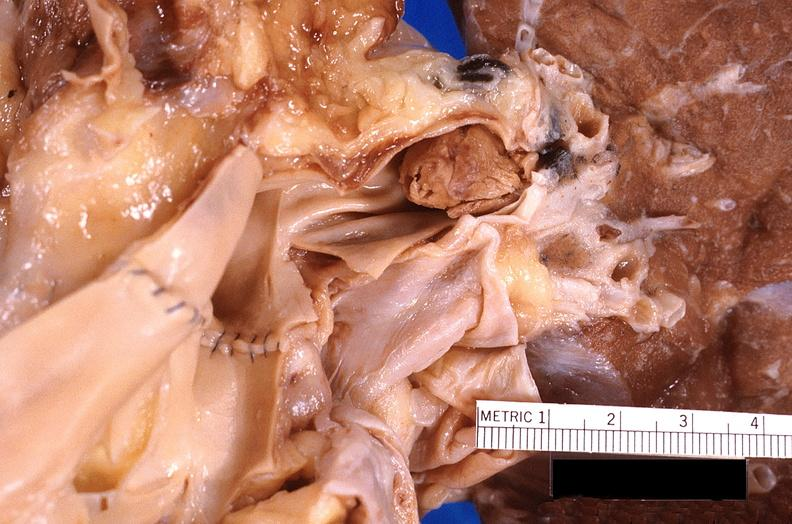where is this?
Answer the question using a single word or phrase. Lung 